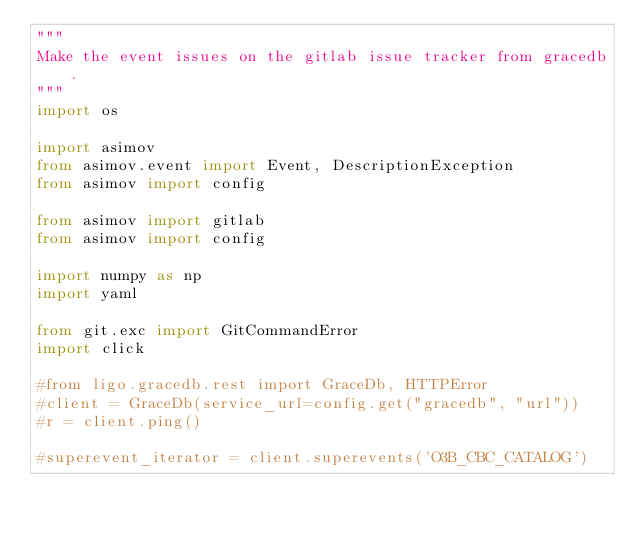<code> <loc_0><loc_0><loc_500><loc_500><_Python_>"""
Make the event issues on the gitlab issue tracker from gracedb.
"""
import os

import asimov
from asimov.event import Event, DescriptionException
from asimov import config

from asimov import gitlab
from asimov import config

import numpy as np
import yaml

from git.exc import GitCommandError
import click

#from ligo.gracedb.rest import GraceDb, HTTPError 
#client = GraceDb(service_url=config.get("gracedb", "url"))
#r = client.ping()

#superevent_iterator = client.superevents('O3B_CBC_CATALOG')</code> 